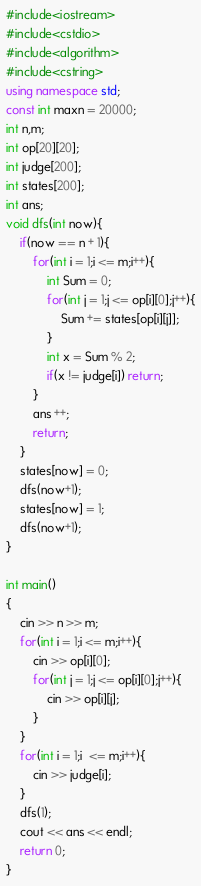<code> <loc_0><loc_0><loc_500><loc_500><_C++_>#include<iostream>
#include<cstdio>
#include<algorithm>
#include<cstring>
using namespace std;
const int maxn = 20000;
int n,m;
int op[20][20];
int judge[200];
int states[200];
int ans;
void dfs(int now){
    if(now == n + 1){
        for(int i = 1;i <= m;i++){
            int Sum = 0;
            for(int j = 1;j <= op[i][0];j++){
                Sum += states[op[i][j]];
            }
            int x = Sum % 2;
            if(x != judge[i]) return;
        }
        ans ++;
        return;
    }
    states[now] = 0;
    dfs(now+1);
    states[now] = 1;
    dfs(now+1);
}

int main()
{
    cin >> n >> m;
    for(int i = 1;i <= m;i++){
        cin >> op[i][0];
        for(int j = 1;j <= op[i][0];j++){
            cin >> op[i][j];
        }
    }
    for(int i = 1;i  <= m;i++){
        cin >> judge[i];
    }
    dfs(1);
    cout << ans << endl;
    return 0;
}</code> 